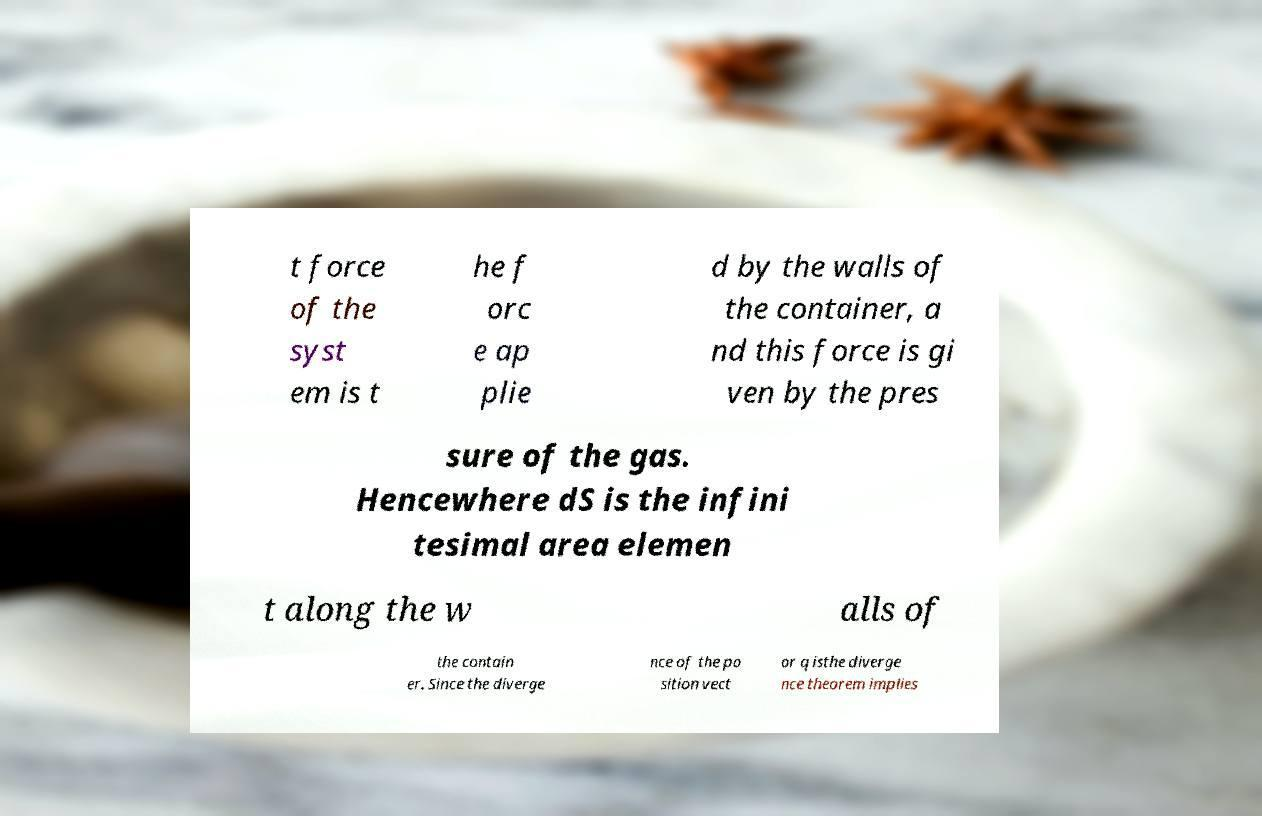Can you read and provide the text displayed in the image?This photo seems to have some interesting text. Can you extract and type it out for me? t force of the syst em is t he f orc e ap plie d by the walls of the container, a nd this force is gi ven by the pres sure of the gas. Hencewhere dS is the infini tesimal area elemen t along the w alls of the contain er. Since the diverge nce of the po sition vect or q isthe diverge nce theorem implies 